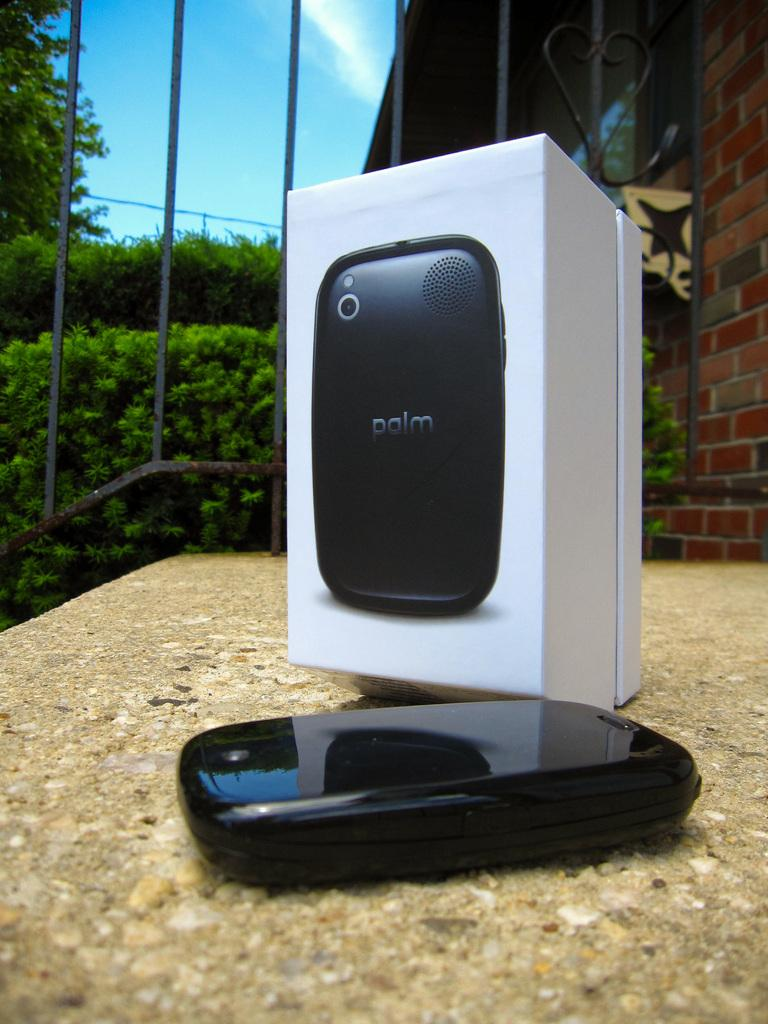<image>
Present a compact description of the photo's key features. an image of a palm phone sitting in front of the box it comes in. 